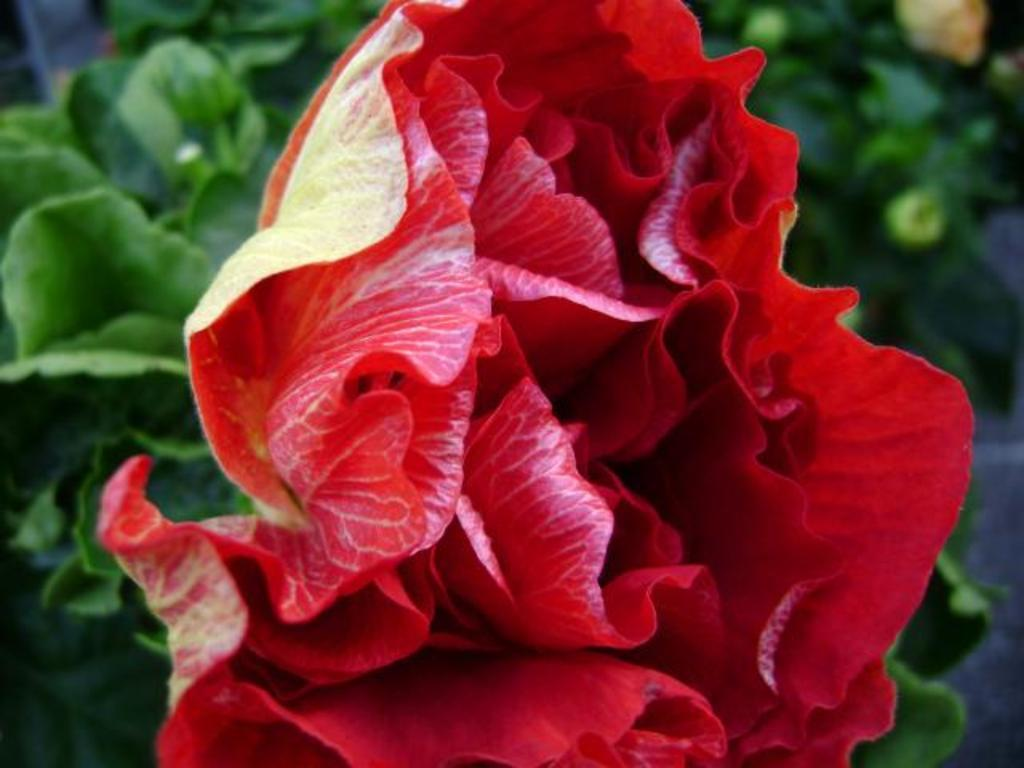What type of flower can be seen in the image? There is a red flower in the image. What else is visible in the background of the image? There are plants in the background of the image. How many wings can be seen on the red flower in the image? There are no wings visible on the red flower in the image, as flowers do not have wings. 